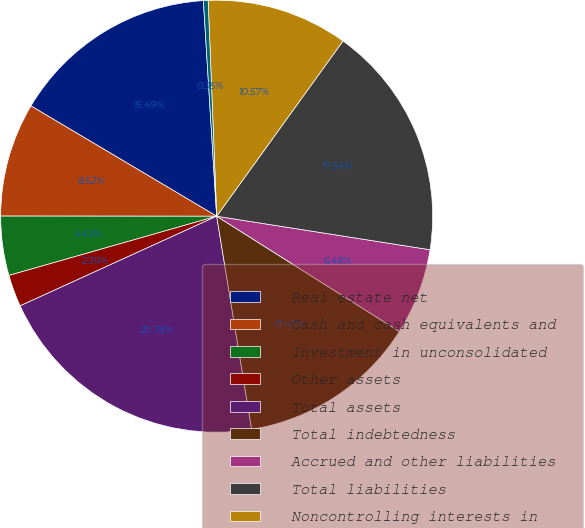<chart> <loc_0><loc_0><loc_500><loc_500><pie_chart><fcel>Real estate net<fcel>Cash and cash equivalents and<fcel>Investment in unconsolidated<fcel>Other assets<fcel>Total assets<fcel>Total indebtedness<fcel>Accrued and other liabilities<fcel>Total liabilities<fcel>Noncontrolling interests in<fcel>Equity attributable to Aimco<nl><fcel>15.49%<fcel>8.52%<fcel>4.43%<fcel>2.39%<fcel>20.78%<fcel>13.45%<fcel>6.48%<fcel>17.54%<fcel>10.57%<fcel>0.35%<nl></chart> 